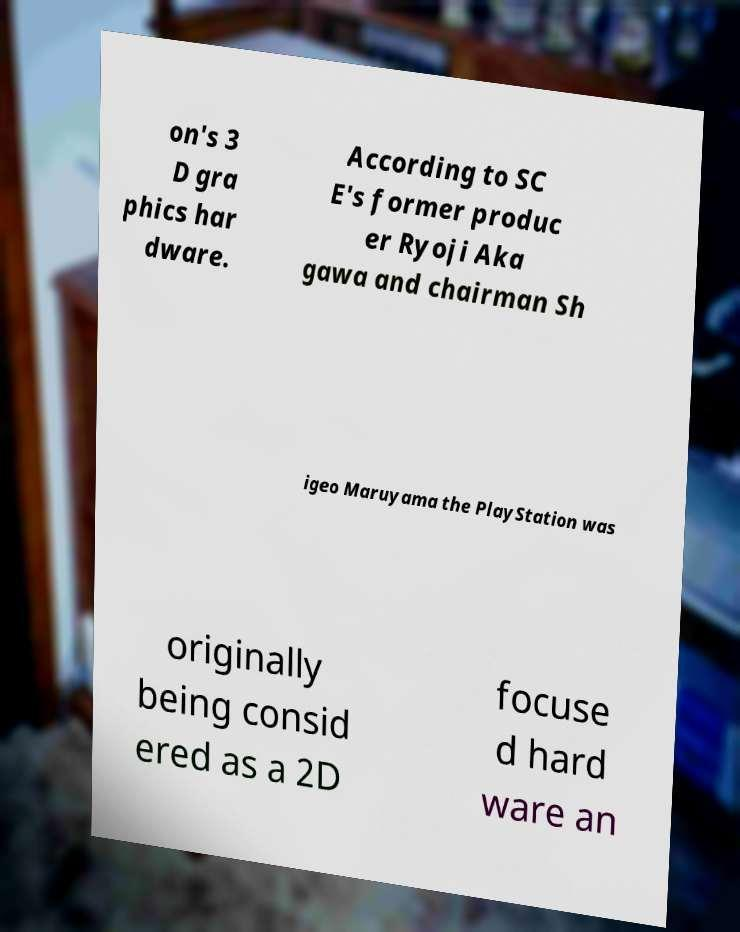There's text embedded in this image that I need extracted. Can you transcribe it verbatim? on's 3 D gra phics har dware. According to SC E's former produc er Ryoji Aka gawa and chairman Sh igeo Maruyama the PlayStation was originally being consid ered as a 2D focuse d hard ware an 